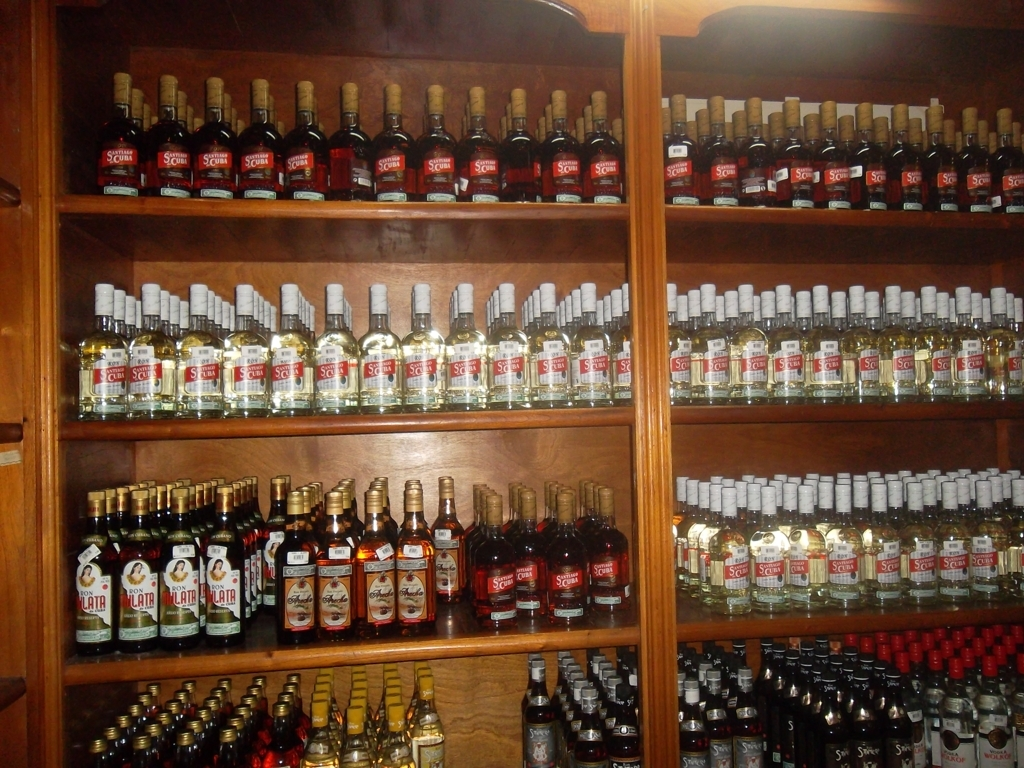Could you give me insight into the cultural significance of the beverages seen in the image? Certainly. The beverages in the image, particularly rum, hold a significant place in various cultures, often associated with social gatherings and traditional events. In some regions, rum has historical importance linked to maritime trade, local agriculture, and historic production processes. It's also a staple in numerous traditional recipes and cocktails, indicative of its deep-rooted influence in culinary and social customs. 